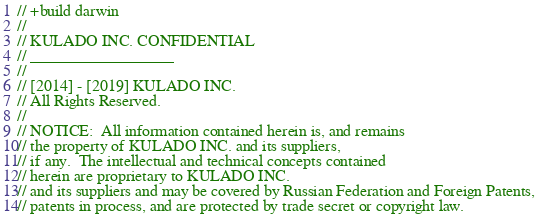Convert code to text. <code><loc_0><loc_0><loc_500><loc_500><_Go_>// +build darwin
//
// KULADO INC. CONFIDENTIAL
// __________________
//
// [2014] - [2019] KULADO INC.
// All Rights Reserved.
//
// NOTICE:  All information contained herein is, and remains
// the property of KULADO INC. and its suppliers,
// if any.  The intellectual and technical concepts contained
// herein are proprietary to KULADO INC.
// and its suppliers and may be covered by Russian Federation and Foreign Patents,
// patents in process, and are protected by trade secret or copyright law.</code> 